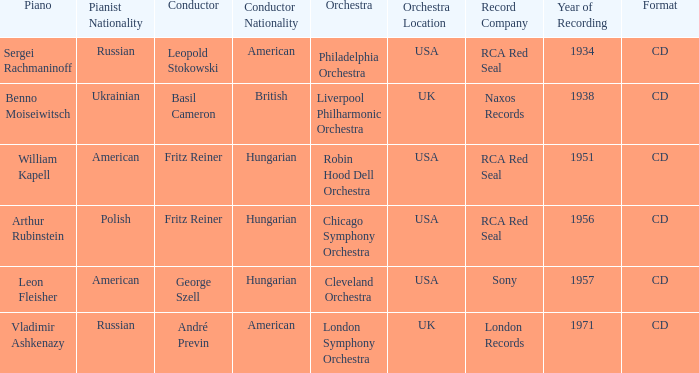Where is the orchestra when the year of recording is 1934? Philadelphia Orchestra. 